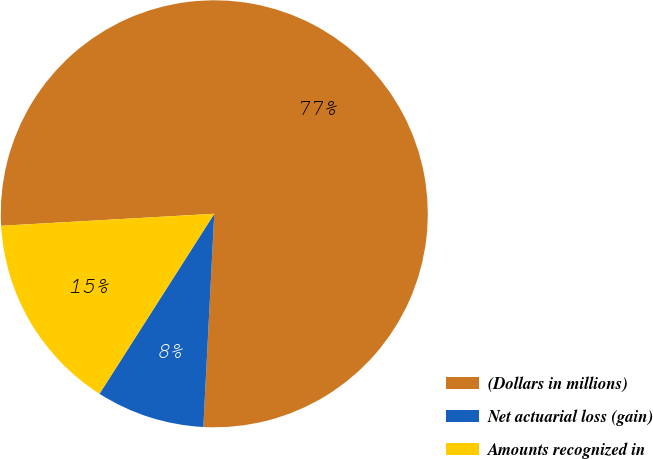Convert chart to OTSL. <chart><loc_0><loc_0><loc_500><loc_500><pie_chart><fcel>(Dollars in millions)<fcel>Net actuarial loss (gain)<fcel>Amounts recognized in<nl><fcel>76.71%<fcel>8.22%<fcel>15.07%<nl></chart> 